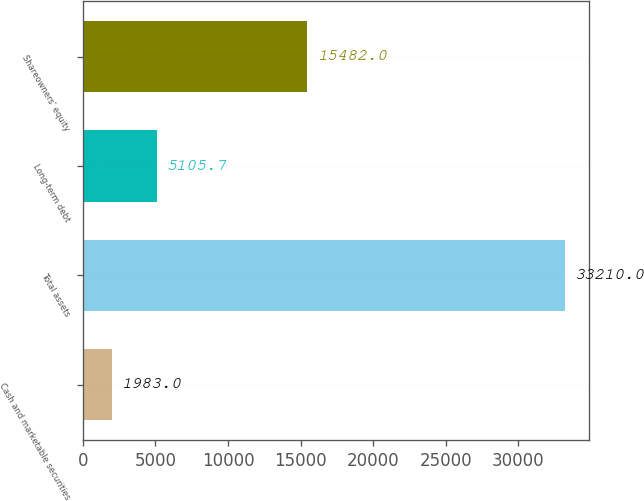Convert chart. <chart><loc_0><loc_0><loc_500><loc_500><bar_chart><fcel>Cash and marketable securities<fcel>Total assets<fcel>Long-term debt<fcel>Shareowners' equity<nl><fcel>1983<fcel>33210<fcel>5105.7<fcel>15482<nl></chart> 